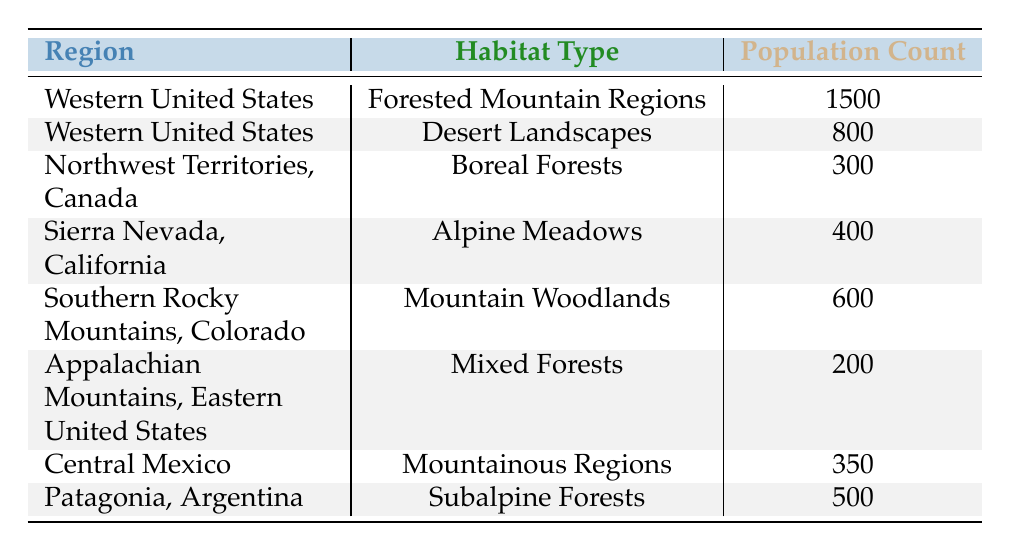What is the population count of mountain lions in the Western United States for Forested Mountain Regions? The table shows that the population count of mountain lions in the Forested Mountain Regions of the Western United States is listed directly as 1500.
Answer: 1500 How many mountain lions are found in Desert Landscapes in the Western United States? The table specifies that the population count in Desert Landscapes for the Western United States is 800.
Answer: 800 What is the total population count of mountain lions in the Northwest Territories, Canada and Appalachian Mountains, Eastern United States combined? The Northwest Territories, Canada has a population of 300, and the Appalachian Mountains, Eastern United States has a population of 200. Adding these gives 300 + 200 = 500.
Answer: 500 Which region has the lowest mountain lion population count, and what is that count? By reviewing the population counts in the table, Appalachian Mountains, Eastern United States has the lowest count of 200.
Answer: 200 Is the population count of mountain lions in Central Mexico greater than that in Patagonia, Argentina? The population count in Central Mexico is 350, while in Patagonia, Argentina it is 500. Since 350 is less than 500, the answer is no.
Answer: No What is the average population count of mountain lions across all listed regions? The total population count from all regions is 1500 + 800 + 300 + 400 + 600 + 200 + 350 + 500 = 4150. There are 8 regions, so the average is 4150 / 8 = 518.75.
Answer: 518.75 In which habitat type do mountain lions prefer to live more based on the highest population count, and what is that count? The highest population count is 1500 in the Forested Mountain Regions of the Western United States, indicating that mountain lions prefer this habitat type the most.
Answer: Forested Mountain Regions, 1500 How many mountain lions are found in Mountain Woodlands in Southern Rocky Mountains, Colorado? The table indicates that the population count for Mountain Woodlands in Southern Rocky Mountains, Colorado is 600.
Answer: 600 Which habitat type has a population count closest to 400 and what is that count? Two habitat types have counts near 400: Alpine Meadows with a count of 400 and Boreal Forests with a count of 300. 400 is exact, which makes it closest, as there's only one entry at 400.
Answer: 400 